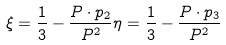<formula> <loc_0><loc_0><loc_500><loc_500>\xi = \frac { 1 } { 3 } - \frac { P \cdot p _ { 2 } } { P ^ { 2 } } \eta = \frac { 1 } { 3 } - \frac { P \cdot p _ { 3 } } { P ^ { 2 } }</formula> 